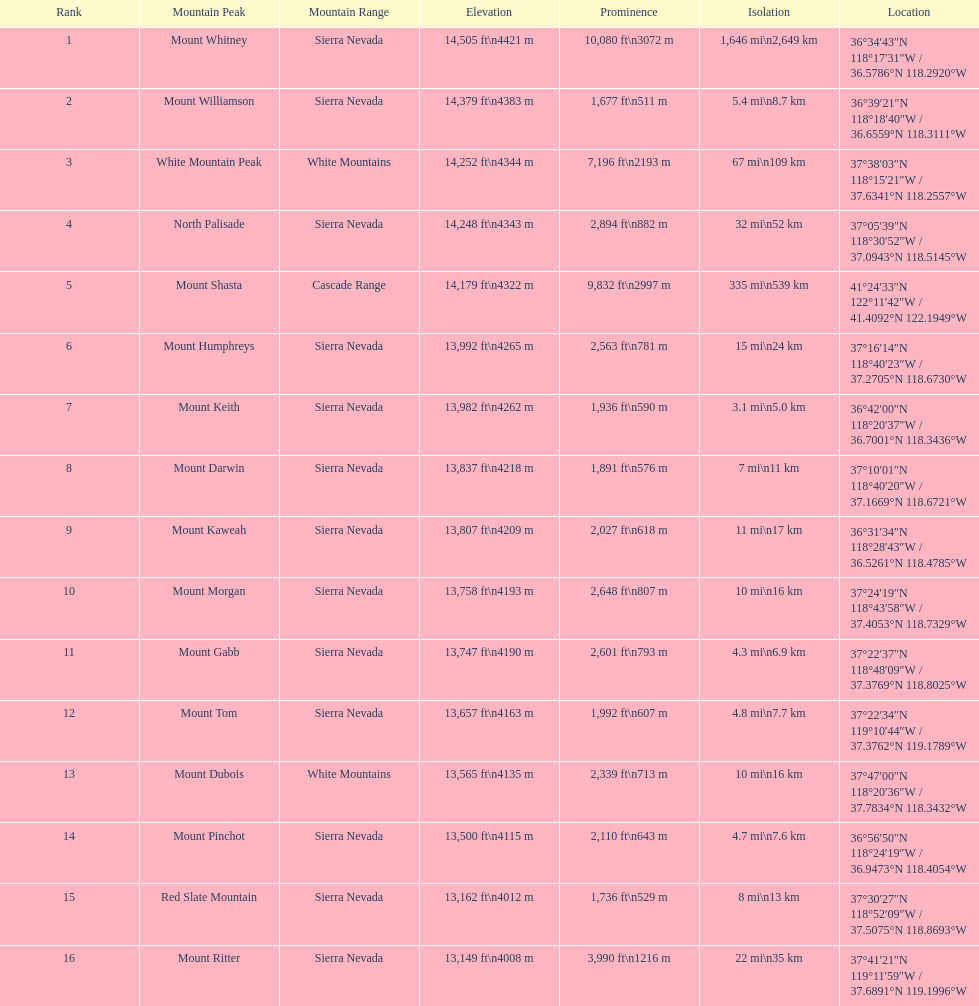Which mountain peak has a prominence more than 10,000 ft? Mount Whitney. 